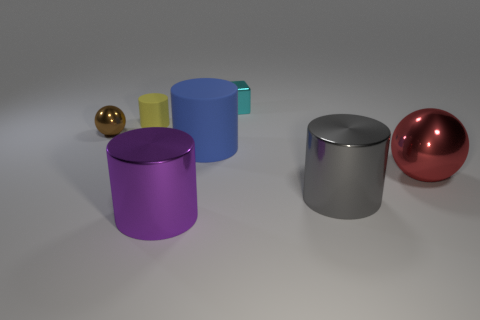Are there any other brown objects made of the same material as the small brown object?
Keep it short and to the point. No. Is the number of large purple metal balls greater than the number of big matte things?
Provide a succinct answer. No. Are the red ball and the tiny yellow cylinder made of the same material?
Your answer should be very brief. No. What number of metal objects are either large cylinders or large gray things?
Provide a succinct answer. 2. There is a ball that is the same size as the cyan metal cube; what is its color?
Your response must be concise. Brown. What number of large gray things have the same shape as the small cyan object?
Your answer should be compact. 0. How many blocks are small matte objects or tiny gray objects?
Your response must be concise. 0. Do the shiny thing that is behind the tiny yellow rubber cylinder and the big metal object that is left of the gray object have the same shape?
Provide a short and direct response. No. What is the small block made of?
Provide a succinct answer. Metal. How many cyan shiny cubes are the same size as the brown thing?
Ensure brevity in your answer.  1. 